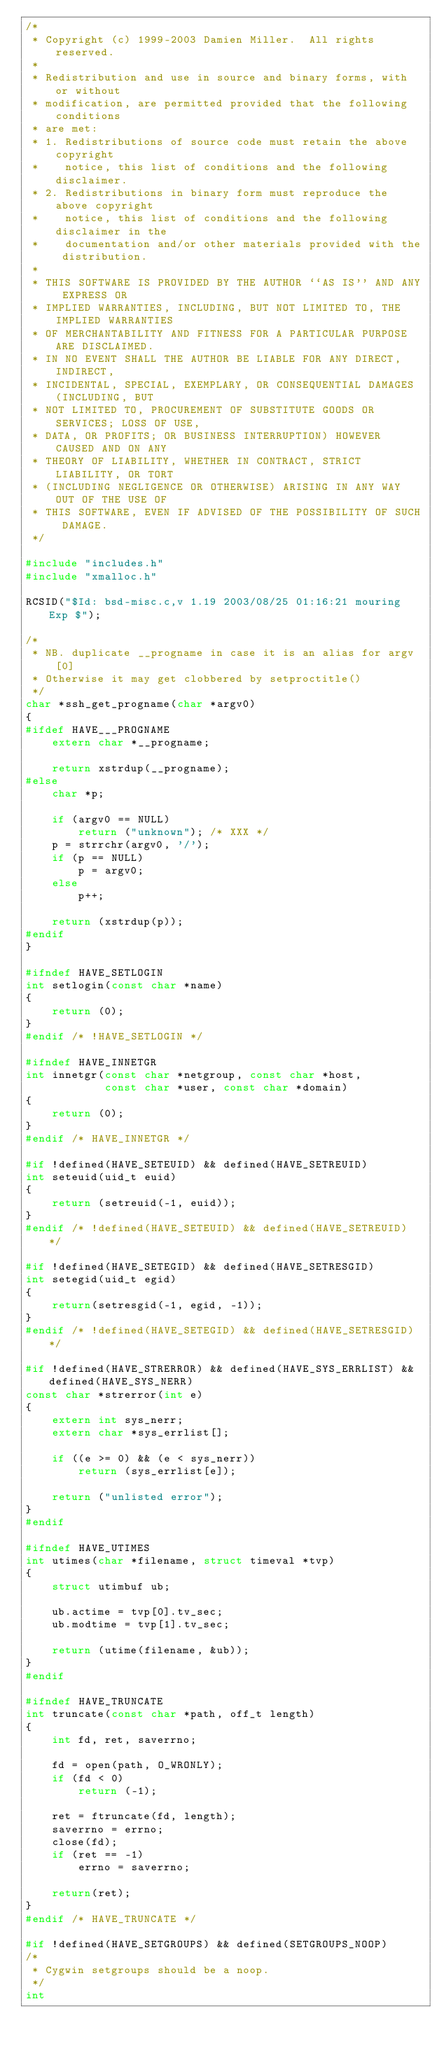Convert code to text. <code><loc_0><loc_0><loc_500><loc_500><_C_>/*
 * Copyright (c) 1999-2003 Damien Miller.  All rights reserved.
 *
 * Redistribution and use in source and binary forms, with or without
 * modification, are permitted provided that the following conditions
 * are met:
 * 1. Redistributions of source code must retain the above copyright
 *    notice, this list of conditions and the following disclaimer.
 * 2. Redistributions in binary form must reproduce the above copyright
 *    notice, this list of conditions and the following disclaimer in the
 *    documentation and/or other materials provided with the distribution.
 *
 * THIS SOFTWARE IS PROVIDED BY THE AUTHOR ``AS IS'' AND ANY EXPRESS OR
 * IMPLIED WARRANTIES, INCLUDING, BUT NOT LIMITED TO, THE IMPLIED WARRANTIES
 * OF MERCHANTABILITY AND FITNESS FOR A PARTICULAR PURPOSE ARE DISCLAIMED.
 * IN NO EVENT SHALL THE AUTHOR BE LIABLE FOR ANY DIRECT, INDIRECT,
 * INCIDENTAL, SPECIAL, EXEMPLARY, OR CONSEQUENTIAL DAMAGES (INCLUDING, BUT
 * NOT LIMITED TO, PROCUREMENT OF SUBSTITUTE GOODS OR SERVICES; LOSS OF USE,
 * DATA, OR PROFITS; OR BUSINESS INTERRUPTION) HOWEVER CAUSED AND ON ANY
 * THEORY OF LIABILITY, WHETHER IN CONTRACT, STRICT LIABILITY, OR TORT
 * (INCLUDING NEGLIGENCE OR OTHERWISE) ARISING IN ANY WAY OUT OF THE USE OF
 * THIS SOFTWARE, EVEN IF ADVISED OF THE POSSIBILITY OF SUCH DAMAGE.
 */

#include "includes.h"
#include "xmalloc.h"

RCSID("$Id: bsd-misc.c,v 1.19 2003/08/25 01:16:21 mouring Exp $");

/*
 * NB. duplicate __progname in case it is an alias for argv[0]
 * Otherwise it may get clobbered by setproctitle()
 */
char *ssh_get_progname(char *argv0)
{
#ifdef HAVE___PROGNAME
	extern char *__progname;

	return xstrdup(__progname);
#else
	char *p;

	if (argv0 == NULL)
		return ("unknown");	/* XXX */
	p = strrchr(argv0, '/');
	if (p == NULL)
		p = argv0;
	else
		p++;

	return (xstrdup(p));
#endif
}

#ifndef HAVE_SETLOGIN
int setlogin(const char *name)
{
	return (0);
}
#endif /* !HAVE_SETLOGIN */

#ifndef HAVE_INNETGR
int innetgr(const char *netgroup, const char *host, 
            const char *user, const char *domain)
{
	return (0);
}
#endif /* HAVE_INNETGR */

#if !defined(HAVE_SETEUID) && defined(HAVE_SETREUID)
int seteuid(uid_t euid)
{
	return (setreuid(-1, euid));
}
#endif /* !defined(HAVE_SETEUID) && defined(HAVE_SETREUID) */

#if !defined(HAVE_SETEGID) && defined(HAVE_SETRESGID)
int setegid(uid_t egid)
{
	return(setresgid(-1, egid, -1));
}
#endif /* !defined(HAVE_SETEGID) && defined(HAVE_SETRESGID) */

#if !defined(HAVE_STRERROR) && defined(HAVE_SYS_ERRLIST) && defined(HAVE_SYS_NERR)
const char *strerror(int e)
{
	extern int sys_nerr;
	extern char *sys_errlist[];
	
	if ((e >= 0) && (e < sys_nerr))
		return (sys_errlist[e]);

	return ("unlisted error");
}
#endif

#ifndef HAVE_UTIMES
int utimes(char *filename, struct timeval *tvp)
{
	struct utimbuf ub;

	ub.actime = tvp[0].tv_sec;
	ub.modtime = tvp[1].tv_sec;
	
	return (utime(filename, &ub));
}
#endif 

#ifndef HAVE_TRUNCATE
int truncate(const char *path, off_t length)
{
	int fd, ret, saverrno;

	fd = open(path, O_WRONLY);
	if (fd < 0)
		return (-1);

	ret = ftruncate(fd, length);
	saverrno = errno;
	close(fd);
	if (ret == -1)
		errno = saverrno;

	return(ret);
}
#endif /* HAVE_TRUNCATE */

#if !defined(HAVE_SETGROUPS) && defined(SETGROUPS_NOOP)
/*
 * Cygwin setgroups should be a noop.
 */
int</code> 